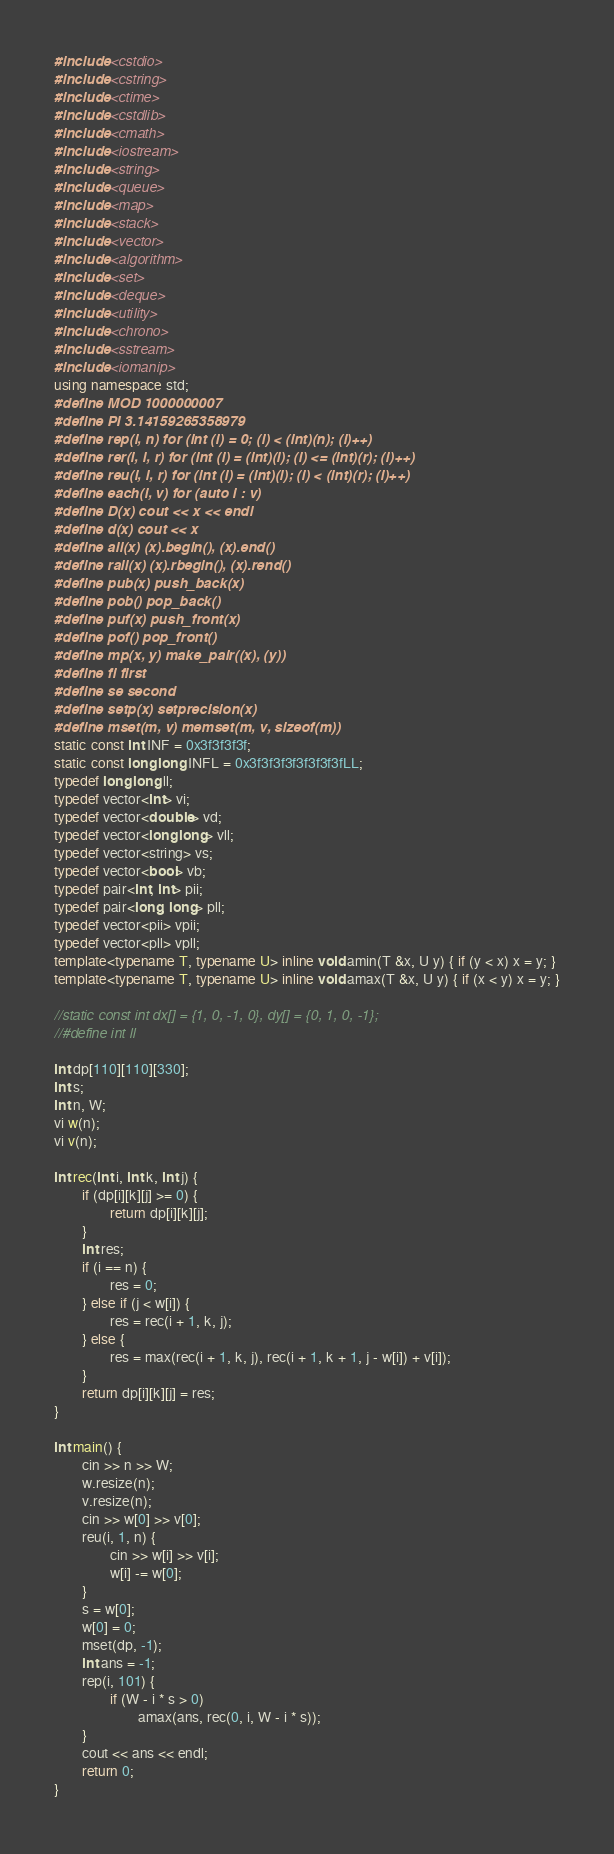<code> <loc_0><loc_0><loc_500><loc_500><_C++_>#include <cstdio>
#include <cstring>
#include <ctime>
#include <cstdlib>
#include <cmath>
#include <iostream>
#include <string>
#include <queue>
#include <map>
#include <stack>
#include <vector>
#include <algorithm>
#include <set>
#include <deque>
#include <utility>
#include <chrono>
#include <sstream>
#include <iomanip>
using namespace std;
#define MOD 1000000007
#define PI 3.14159265358979
#define rep(i, n) for (int (i) = 0; (i) < (int)(n); (i)++)
#define rer(i, l, r) for (int (i) = (int)(l); (i) <= (int)(r); (i)++)
#define reu(i, l, r) for (int (i) = (int)(l); (i) < (int)(r); (i)++)
#define each(i, v) for (auto i : v)
#define D(x) cout << x << endl
#define d(x) cout << x
#define all(x) (x).begin(), (x).end()
#define rall(x) (x).rbegin(), (x).rend()
#define pub(x) push_back(x)
#define pob() pop_back()
#define puf(x) push_front(x)
#define pof() pop_front()
#define mp(x, y) make_pair((x), (y))
#define fi first
#define se second
#define setp(x) setprecision(x)
#define mset(m, v) memset(m, v, sizeof(m))
static const int INF = 0x3f3f3f3f;
static const long long INFL = 0x3f3f3f3f3f3f3f3fLL;
typedef long long ll;
typedef vector<int> vi;
typedef vector<double> vd;
typedef vector<long long> vll;
typedef vector<string> vs;
typedef vector<bool> vb;
typedef pair<int, int> pii;
typedef pair<long, long> pll;
typedef vector<pii> vpii;
typedef vector<pll> vpll;
template<typename T, typename U> inline void amin(T &x, U y) { if (y < x) x = y; }
template<typename T, typename U> inline void amax(T &x, U y) { if (x < y) x = y; }

//static const int dx[] = {1, 0, -1, 0}, dy[] = {0, 1, 0, -1};
//#define int ll

int dp[110][110][330];
int s;
int n, W;
vi w(n);
vi v(n);

int rec(int i, int k, int j) {
        if (dp[i][k][j] >= 0) {
                return dp[i][k][j];
        }
        int res;
        if (i == n) {
                res = 0;
        } else if (j < w[i]) {
                res = rec(i + 1, k, j);
        } else {
                res = max(rec(i + 1, k, j), rec(i + 1, k + 1, j - w[i]) + v[i]);
        }
        return dp[i][k][j] = res;
}

int main() { 
        cin >> n >> W;
        w.resize(n);
        v.resize(n);
        cin >> w[0] >> v[0];
        reu(i, 1, n) {
                cin >> w[i] >> v[i];
                w[i] -= w[0];
        }
        s = w[0];
        w[0] = 0;
        mset(dp, -1);
        int ans = -1;
        rep(i, 101) {
                if (W - i * s > 0) 
                        amax(ans, rec(0, i, W - i * s));
        }
        cout << ans << endl;
        return 0;
}

</code> 